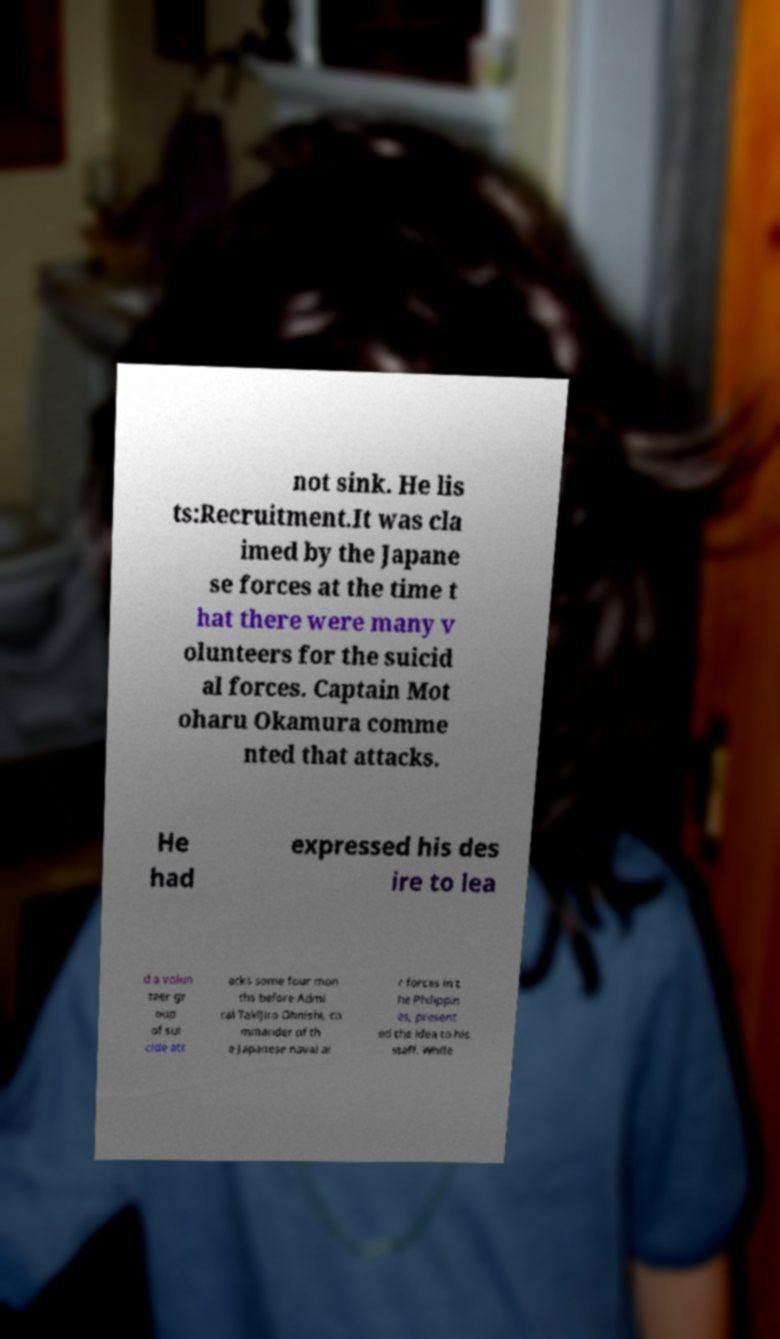What messages or text are displayed in this image? I need them in a readable, typed format. not sink. He lis ts:Recruitment.It was cla imed by the Japane se forces at the time t hat there were many v olunteers for the suicid al forces. Captain Mot oharu Okamura comme nted that attacks. He had expressed his des ire to lea d a volun teer gr oup of sui cide att acks some four mon ths before Admi ral Takijiro Ohnishi, co mmander of th e Japanese naval ai r forces in t he Philippin es, present ed the idea to his staff. While 